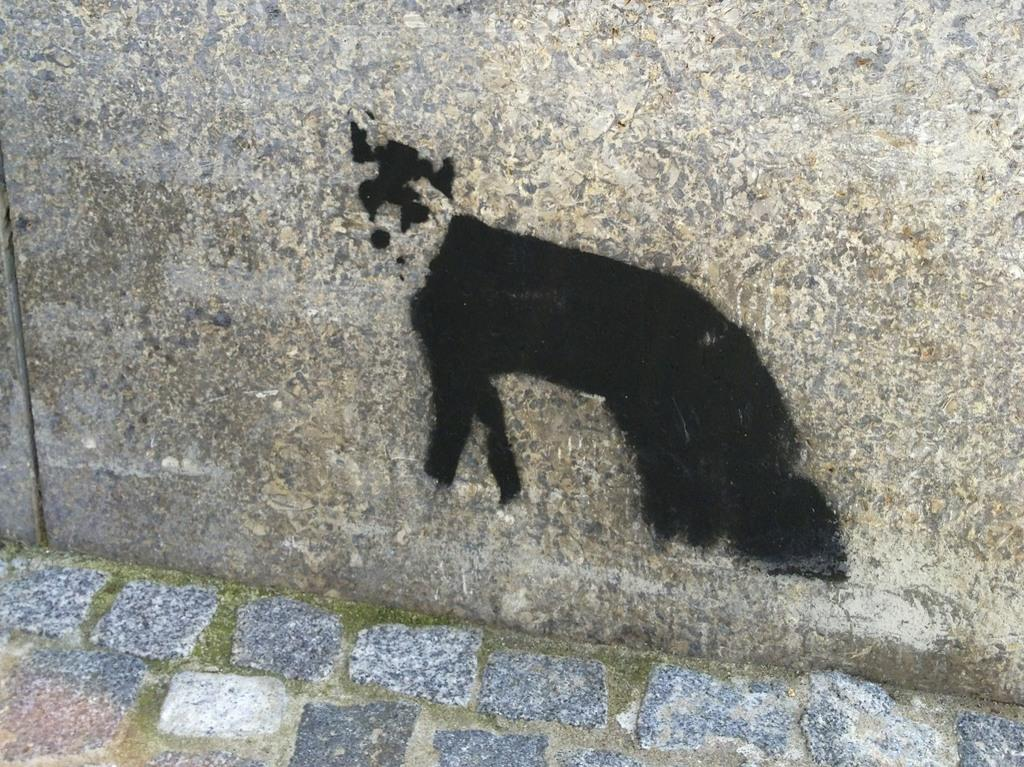What type of artwork is depicted in the image? The image is a painting on the wall. What color is the painting? The painting is in black color. How many yaks are depicted in the painting? There are no yaks present in the painting; it is entirely in black color. Are there any goats or brothers in the painting? There is no reference to goats or brothers in the painting, as it is solely in black color. 